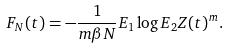<formula> <loc_0><loc_0><loc_500><loc_500>F _ { N } ( t ) = - \frac { 1 } { m \beta N } E _ { 1 } \log E _ { 2 } Z ( t ) ^ { m } .</formula> 